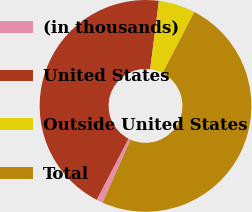Convert chart to OTSL. <chart><loc_0><loc_0><loc_500><loc_500><pie_chart><fcel>(in thousands)<fcel>United States<fcel>Outside United States<fcel>Total<nl><fcel>0.98%<fcel>44.39%<fcel>5.61%<fcel>49.02%<nl></chart> 